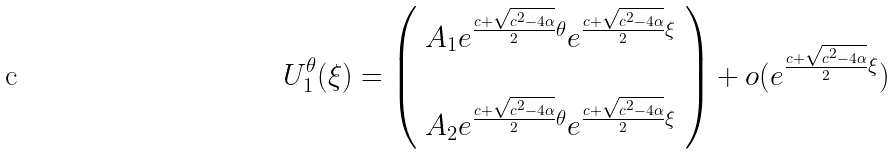Convert formula to latex. <formula><loc_0><loc_0><loc_500><loc_500>U _ { 1 } ^ { \theta } ( \xi ) = \left ( \begin{array} { c } A _ { 1 } e ^ { \frac { c + \sqrt { c ^ { 2 } - 4 \alpha } } { 2 } \theta } e ^ { \frac { c + \sqrt { c ^ { 2 } - 4 \alpha } } { 2 } \xi } \\ \\ A _ { 2 } e ^ { \frac { c + \sqrt { c ^ { 2 } - 4 \alpha } } { 2 } \theta } e ^ { \frac { c + \sqrt { c ^ { 2 } - 4 \alpha } } { 2 } \xi } \end{array} \right ) + o ( e ^ { \frac { c + \sqrt { c ^ { 2 } - 4 \alpha } } { 2 } \xi } )</formula> 